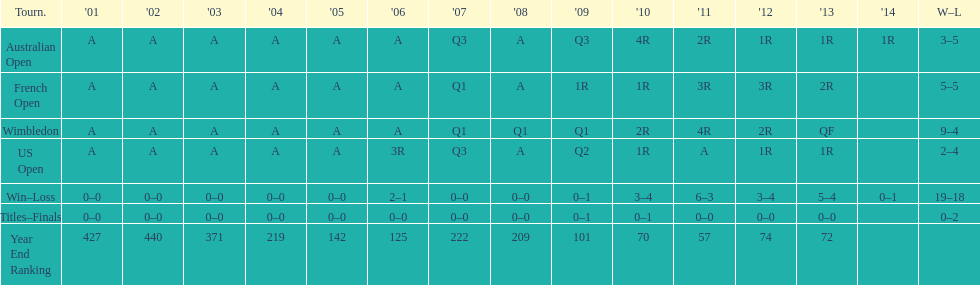Parse the full table. {'header': ['Tourn.', "'01", "'02", "'03", "'04", "'05", "'06", "'07", "'08", "'09", "'10", "'11", "'12", "'13", "'14", 'W–L'], 'rows': [['Australian Open', 'A', 'A', 'A', 'A', 'A', 'A', 'Q3', 'A', 'Q3', '4R', '2R', '1R', '1R', '1R', '3–5'], ['French Open', 'A', 'A', 'A', 'A', 'A', 'A', 'Q1', 'A', '1R', '1R', '3R', '3R', '2R', '', '5–5'], ['Wimbledon', 'A', 'A', 'A', 'A', 'A', 'A', 'Q1', 'Q1', 'Q1', '2R', '4R', '2R', 'QF', '', '9–4'], ['US Open', 'A', 'A', 'A', 'A', 'A', '3R', 'Q3', 'A', 'Q2', '1R', 'A', '1R', '1R', '', '2–4'], ['Win–Loss', '0–0', '0–0', '0–0', '0–0', '0–0', '2–1', '0–0', '0–0', '0–1', '3–4', '6–3', '3–4', '5–4', '0–1', '19–18'], ['Titles–Finals', '0–0', '0–0', '0–0', '0–0', '0–0', '0–0', '0–0', '0–0', '0–1', '0–1', '0–0', '0–0', '0–0', '', '0–2'], ['Year End Ranking', '427', '440', '371', '219', '142', '125', '222', '209', '101', '70', '57', '74', '72', '', '']]} Which tournament has the largest total win record? Wimbledon. 